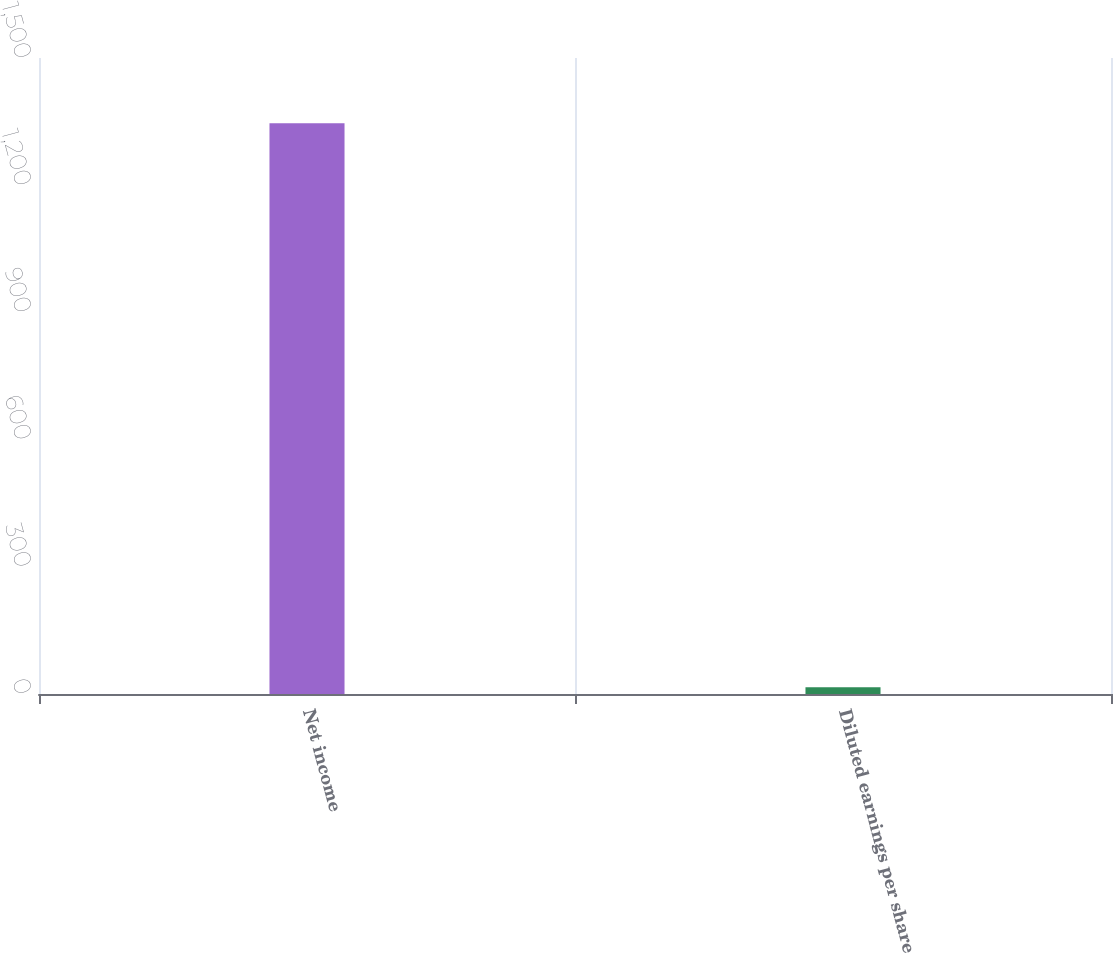<chart> <loc_0><loc_0><loc_500><loc_500><bar_chart><fcel>Net income<fcel>Diluted earnings per share<nl><fcel>1346<fcel>15.73<nl></chart> 